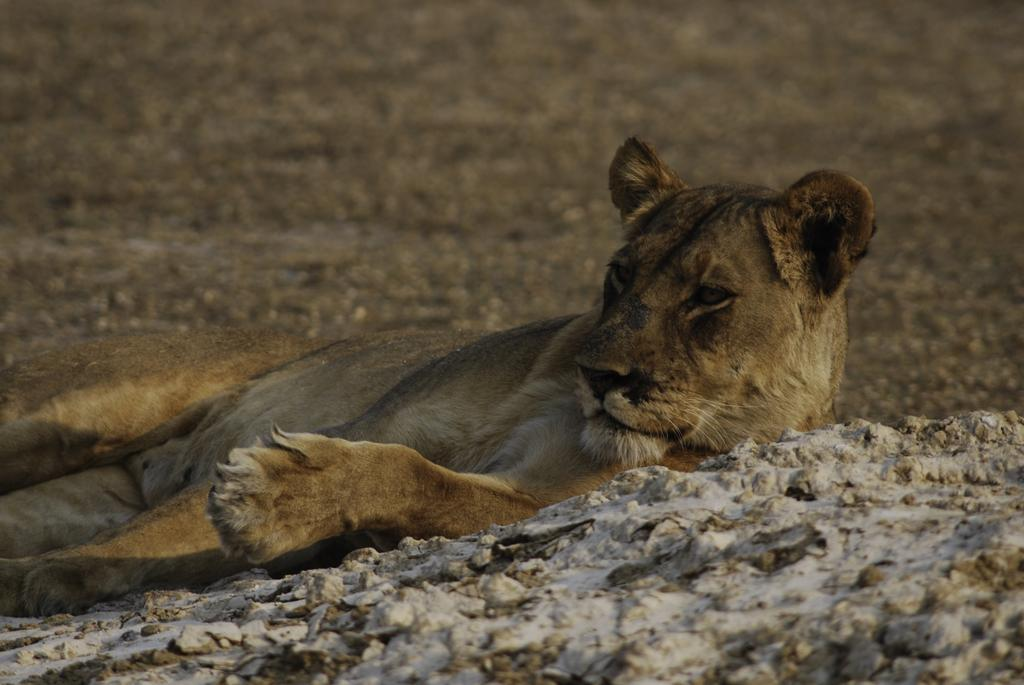What animal is present in the image? There is a lion in the image. What can be seen beneath the lion? The ground is visible in the image. What type of objects are present on the ground? There are stones in the image. What type of muscle can be seen in the lion's body in the image? There is no visible muscle in the lion's body in the image; it is a photograph of the lion, not an anatomical illustration. 